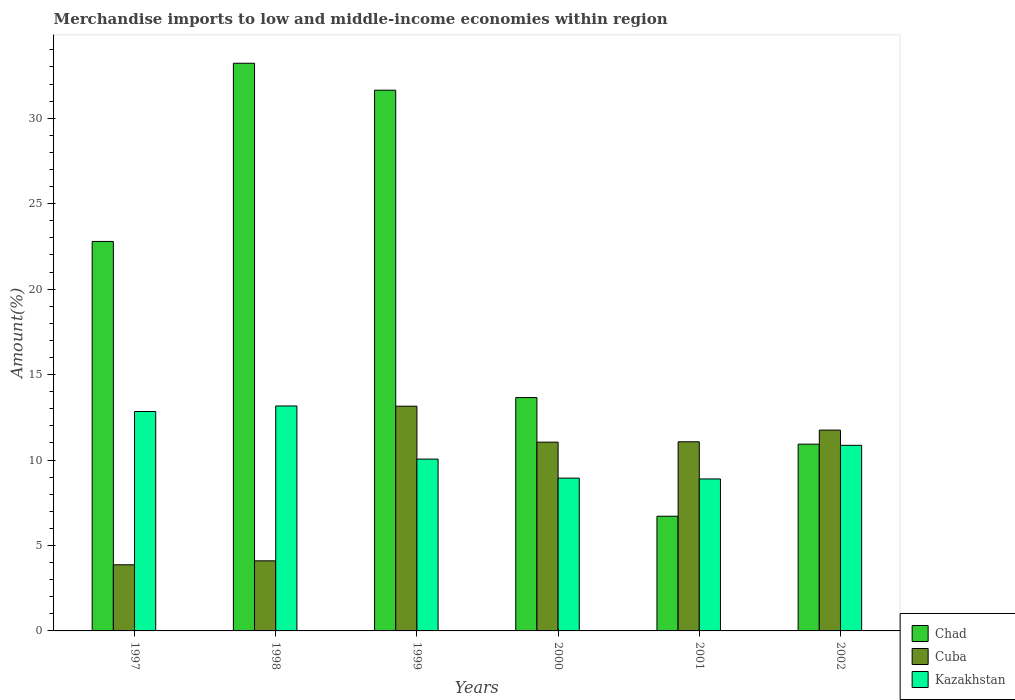How many different coloured bars are there?
Provide a succinct answer. 3. Are the number of bars per tick equal to the number of legend labels?
Provide a short and direct response. Yes. What is the label of the 5th group of bars from the left?
Offer a terse response. 2001. In how many cases, is the number of bars for a given year not equal to the number of legend labels?
Ensure brevity in your answer.  0. What is the percentage of amount earned from merchandise imports in Kazakhstan in 1998?
Provide a short and direct response. 13.16. Across all years, what is the maximum percentage of amount earned from merchandise imports in Cuba?
Offer a very short reply. 13.15. Across all years, what is the minimum percentage of amount earned from merchandise imports in Chad?
Your answer should be very brief. 6.71. In which year was the percentage of amount earned from merchandise imports in Chad minimum?
Make the answer very short. 2001. What is the total percentage of amount earned from merchandise imports in Kazakhstan in the graph?
Offer a very short reply. 64.75. What is the difference between the percentage of amount earned from merchandise imports in Cuba in 1997 and that in 1999?
Give a very brief answer. -9.28. What is the difference between the percentage of amount earned from merchandise imports in Kazakhstan in 1998 and the percentage of amount earned from merchandise imports in Chad in 2002?
Offer a very short reply. 2.24. What is the average percentage of amount earned from merchandise imports in Chad per year?
Your answer should be very brief. 19.82. In the year 1997, what is the difference between the percentage of amount earned from merchandise imports in Chad and percentage of amount earned from merchandise imports in Cuba?
Keep it short and to the point. 18.92. What is the ratio of the percentage of amount earned from merchandise imports in Kazakhstan in 1998 to that in 2001?
Offer a very short reply. 1.48. What is the difference between the highest and the second highest percentage of amount earned from merchandise imports in Kazakhstan?
Your answer should be compact. 0.32. What is the difference between the highest and the lowest percentage of amount earned from merchandise imports in Kazakhstan?
Make the answer very short. 4.27. What does the 3rd bar from the left in 2002 represents?
Ensure brevity in your answer.  Kazakhstan. What does the 2nd bar from the right in 2000 represents?
Make the answer very short. Cuba. Is it the case that in every year, the sum of the percentage of amount earned from merchandise imports in Kazakhstan and percentage of amount earned from merchandise imports in Chad is greater than the percentage of amount earned from merchandise imports in Cuba?
Your response must be concise. Yes. How many bars are there?
Offer a terse response. 18. Are all the bars in the graph horizontal?
Give a very brief answer. No. How many years are there in the graph?
Your answer should be compact. 6. Are the values on the major ticks of Y-axis written in scientific E-notation?
Your answer should be compact. No. Does the graph contain grids?
Offer a very short reply. No. How are the legend labels stacked?
Offer a terse response. Vertical. What is the title of the graph?
Offer a terse response. Merchandise imports to low and middle-income economies within region. Does "Nigeria" appear as one of the legend labels in the graph?
Offer a very short reply. No. What is the label or title of the X-axis?
Your response must be concise. Years. What is the label or title of the Y-axis?
Provide a succinct answer. Amount(%). What is the Amount(%) of Chad in 1997?
Your response must be concise. 22.79. What is the Amount(%) in Cuba in 1997?
Your answer should be compact. 3.87. What is the Amount(%) in Kazakhstan in 1997?
Your answer should be compact. 12.84. What is the Amount(%) of Chad in 1998?
Provide a short and direct response. 33.21. What is the Amount(%) in Cuba in 1998?
Your answer should be very brief. 4.1. What is the Amount(%) in Kazakhstan in 1998?
Offer a very short reply. 13.16. What is the Amount(%) in Chad in 1999?
Your answer should be compact. 31.64. What is the Amount(%) of Cuba in 1999?
Give a very brief answer. 13.15. What is the Amount(%) in Kazakhstan in 1999?
Your response must be concise. 10.05. What is the Amount(%) of Chad in 2000?
Make the answer very short. 13.65. What is the Amount(%) of Cuba in 2000?
Provide a succinct answer. 11.05. What is the Amount(%) in Kazakhstan in 2000?
Your response must be concise. 8.94. What is the Amount(%) of Chad in 2001?
Make the answer very short. 6.71. What is the Amount(%) in Cuba in 2001?
Make the answer very short. 11.07. What is the Amount(%) in Kazakhstan in 2001?
Ensure brevity in your answer.  8.89. What is the Amount(%) of Chad in 2002?
Make the answer very short. 10.93. What is the Amount(%) in Cuba in 2002?
Give a very brief answer. 11.75. What is the Amount(%) of Kazakhstan in 2002?
Provide a short and direct response. 10.86. Across all years, what is the maximum Amount(%) in Chad?
Provide a short and direct response. 33.21. Across all years, what is the maximum Amount(%) of Cuba?
Offer a very short reply. 13.15. Across all years, what is the maximum Amount(%) of Kazakhstan?
Provide a succinct answer. 13.16. Across all years, what is the minimum Amount(%) of Chad?
Ensure brevity in your answer.  6.71. Across all years, what is the minimum Amount(%) of Cuba?
Provide a succinct answer. 3.87. Across all years, what is the minimum Amount(%) in Kazakhstan?
Offer a terse response. 8.89. What is the total Amount(%) in Chad in the graph?
Provide a short and direct response. 118.93. What is the total Amount(%) of Cuba in the graph?
Keep it short and to the point. 54.98. What is the total Amount(%) in Kazakhstan in the graph?
Ensure brevity in your answer.  64.75. What is the difference between the Amount(%) in Chad in 1997 and that in 1998?
Your answer should be compact. -10.43. What is the difference between the Amount(%) of Cuba in 1997 and that in 1998?
Ensure brevity in your answer.  -0.23. What is the difference between the Amount(%) in Kazakhstan in 1997 and that in 1998?
Keep it short and to the point. -0.32. What is the difference between the Amount(%) in Chad in 1997 and that in 1999?
Provide a short and direct response. -8.85. What is the difference between the Amount(%) in Cuba in 1997 and that in 1999?
Ensure brevity in your answer.  -9.28. What is the difference between the Amount(%) of Kazakhstan in 1997 and that in 1999?
Keep it short and to the point. 2.79. What is the difference between the Amount(%) of Chad in 1997 and that in 2000?
Give a very brief answer. 9.13. What is the difference between the Amount(%) in Cuba in 1997 and that in 2000?
Your response must be concise. -7.18. What is the difference between the Amount(%) of Kazakhstan in 1997 and that in 2000?
Give a very brief answer. 3.9. What is the difference between the Amount(%) in Chad in 1997 and that in 2001?
Give a very brief answer. 16.08. What is the difference between the Amount(%) in Cuba in 1997 and that in 2001?
Offer a very short reply. -7.2. What is the difference between the Amount(%) of Kazakhstan in 1997 and that in 2001?
Your response must be concise. 3.95. What is the difference between the Amount(%) of Chad in 1997 and that in 2002?
Provide a short and direct response. 11.86. What is the difference between the Amount(%) in Cuba in 1997 and that in 2002?
Offer a terse response. -7.88. What is the difference between the Amount(%) of Kazakhstan in 1997 and that in 2002?
Give a very brief answer. 1.98. What is the difference between the Amount(%) in Chad in 1998 and that in 1999?
Give a very brief answer. 1.58. What is the difference between the Amount(%) in Cuba in 1998 and that in 1999?
Provide a short and direct response. -9.05. What is the difference between the Amount(%) of Kazakhstan in 1998 and that in 1999?
Ensure brevity in your answer.  3.11. What is the difference between the Amount(%) of Chad in 1998 and that in 2000?
Give a very brief answer. 19.56. What is the difference between the Amount(%) in Cuba in 1998 and that in 2000?
Give a very brief answer. -6.94. What is the difference between the Amount(%) of Kazakhstan in 1998 and that in 2000?
Provide a succinct answer. 4.22. What is the difference between the Amount(%) of Chad in 1998 and that in 2001?
Ensure brevity in your answer.  26.5. What is the difference between the Amount(%) in Cuba in 1998 and that in 2001?
Give a very brief answer. -6.97. What is the difference between the Amount(%) in Kazakhstan in 1998 and that in 2001?
Provide a succinct answer. 4.27. What is the difference between the Amount(%) in Chad in 1998 and that in 2002?
Your answer should be compact. 22.29. What is the difference between the Amount(%) in Cuba in 1998 and that in 2002?
Make the answer very short. -7.65. What is the difference between the Amount(%) in Kazakhstan in 1998 and that in 2002?
Make the answer very short. 2.3. What is the difference between the Amount(%) in Chad in 1999 and that in 2000?
Keep it short and to the point. 17.98. What is the difference between the Amount(%) of Cuba in 1999 and that in 2000?
Your answer should be very brief. 2.1. What is the difference between the Amount(%) of Kazakhstan in 1999 and that in 2000?
Your answer should be compact. 1.11. What is the difference between the Amount(%) of Chad in 1999 and that in 2001?
Make the answer very short. 24.93. What is the difference between the Amount(%) in Cuba in 1999 and that in 2001?
Provide a short and direct response. 2.08. What is the difference between the Amount(%) in Kazakhstan in 1999 and that in 2001?
Provide a succinct answer. 1.16. What is the difference between the Amount(%) in Chad in 1999 and that in 2002?
Your answer should be very brief. 20.71. What is the difference between the Amount(%) of Cuba in 1999 and that in 2002?
Provide a short and direct response. 1.4. What is the difference between the Amount(%) of Kazakhstan in 1999 and that in 2002?
Provide a short and direct response. -0.81. What is the difference between the Amount(%) in Chad in 2000 and that in 2001?
Give a very brief answer. 6.94. What is the difference between the Amount(%) of Cuba in 2000 and that in 2001?
Keep it short and to the point. -0.02. What is the difference between the Amount(%) of Kazakhstan in 2000 and that in 2001?
Your answer should be very brief. 0.05. What is the difference between the Amount(%) in Chad in 2000 and that in 2002?
Give a very brief answer. 2.73. What is the difference between the Amount(%) in Cuba in 2000 and that in 2002?
Ensure brevity in your answer.  -0.71. What is the difference between the Amount(%) of Kazakhstan in 2000 and that in 2002?
Your answer should be compact. -1.92. What is the difference between the Amount(%) in Chad in 2001 and that in 2002?
Offer a terse response. -4.22. What is the difference between the Amount(%) of Cuba in 2001 and that in 2002?
Give a very brief answer. -0.68. What is the difference between the Amount(%) of Kazakhstan in 2001 and that in 2002?
Give a very brief answer. -1.97. What is the difference between the Amount(%) in Chad in 1997 and the Amount(%) in Cuba in 1998?
Your answer should be very brief. 18.69. What is the difference between the Amount(%) of Chad in 1997 and the Amount(%) of Kazakhstan in 1998?
Your response must be concise. 9.63. What is the difference between the Amount(%) of Cuba in 1997 and the Amount(%) of Kazakhstan in 1998?
Offer a terse response. -9.29. What is the difference between the Amount(%) of Chad in 1997 and the Amount(%) of Cuba in 1999?
Your response must be concise. 9.64. What is the difference between the Amount(%) of Chad in 1997 and the Amount(%) of Kazakhstan in 1999?
Your answer should be compact. 12.74. What is the difference between the Amount(%) of Cuba in 1997 and the Amount(%) of Kazakhstan in 1999?
Provide a short and direct response. -6.18. What is the difference between the Amount(%) in Chad in 1997 and the Amount(%) in Cuba in 2000?
Provide a short and direct response. 11.74. What is the difference between the Amount(%) of Chad in 1997 and the Amount(%) of Kazakhstan in 2000?
Offer a terse response. 13.85. What is the difference between the Amount(%) in Cuba in 1997 and the Amount(%) in Kazakhstan in 2000?
Ensure brevity in your answer.  -5.07. What is the difference between the Amount(%) of Chad in 1997 and the Amount(%) of Cuba in 2001?
Provide a succinct answer. 11.72. What is the difference between the Amount(%) of Chad in 1997 and the Amount(%) of Kazakhstan in 2001?
Keep it short and to the point. 13.9. What is the difference between the Amount(%) of Cuba in 1997 and the Amount(%) of Kazakhstan in 2001?
Provide a succinct answer. -5.02. What is the difference between the Amount(%) in Chad in 1997 and the Amount(%) in Cuba in 2002?
Ensure brevity in your answer.  11.04. What is the difference between the Amount(%) of Chad in 1997 and the Amount(%) of Kazakhstan in 2002?
Offer a terse response. 11.93. What is the difference between the Amount(%) in Cuba in 1997 and the Amount(%) in Kazakhstan in 2002?
Keep it short and to the point. -6.99. What is the difference between the Amount(%) in Chad in 1998 and the Amount(%) in Cuba in 1999?
Provide a short and direct response. 20.07. What is the difference between the Amount(%) in Chad in 1998 and the Amount(%) in Kazakhstan in 1999?
Provide a short and direct response. 23.16. What is the difference between the Amount(%) of Cuba in 1998 and the Amount(%) of Kazakhstan in 1999?
Your response must be concise. -5.95. What is the difference between the Amount(%) of Chad in 1998 and the Amount(%) of Cuba in 2000?
Give a very brief answer. 22.17. What is the difference between the Amount(%) in Chad in 1998 and the Amount(%) in Kazakhstan in 2000?
Your answer should be very brief. 24.27. What is the difference between the Amount(%) of Cuba in 1998 and the Amount(%) of Kazakhstan in 2000?
Your response must be concise. -4.84. What is the difference between the Amount(%) of Chad in 1998 and the Amount(%) of Cuba in 2001?
Give a very brief answer. 22.15. What is the difference between the Amount(%) in Chad in 1998 and the Amount(%) in Kazakhstan in 2001?
Offer a very short reply. 24.32. What is the difference between the Amount(%) in Cuba in 1998 and the Amount(%) in Kazakhstan in 2001?
Ensure brevity in your answer.  -4.79. What is the difference between the Amount(%) of Chad in 1998 and the Amount(%) of Cuba in 2002?
Make the answer very short. 21.46. What is the difference between the Amount(%) in Chad in 1998 and the Amount(%) in Kazakhstan in 2002?
Provide a succinct answer. 22.35. What is the difference between the Amount(%) in Cuba in 1998 and the Amount(%) in Kazakhstan in 2002?
Offer a terse response. -6.76. What is the difference between the Amount(%) of Chad in 1999 and the Amount(%) of Cuba in 2000?
Offer a very short reply. 20.59. What is the difference between the Amount(%) in Chad in 1999 and the Amount(%) in Kazakhstan in 2000?
Ensure brevity in your answer.  22.7. What is the difference between the Amount(%) of Cuba in 1999 and the Amount(%) of Kazakhstan in 2000?
Your answer should be very brief. 4.21. What is the difference between the Amount(%) in Chad in 1999 and the Amount(%) in Cuba in 2001?
Give a very brief answer. 20.57. What is the difference between the Amount(%) of Chad in 1999 and the Amount(%) of Kazakhstan in 2001?
Your answer should be compact. 22.75. What is the difference between the Amount(%) of Cuba in 1999 and the Amount(%) of Kazakhstan in 2001?
Provide a succinct answer. 4.26. What is the difference between the Amount(%) in Chad in 1999 and the Amount(%) in Cuba in 2002?
Keep it short and to the point. 19.89. What is the difference between the Amount(%) in Chad in 1999 and the Amount(%) in Kazakhstan in 2002?
Give a very brief answer. 20.78. What is the difference between the Amount(%) of Cuba in 1999 and the Amount(%) of Kazakhstan in 2002?
Offer a terse response. 2.29. What is the difference between the Amount(%) of Chad in 2000 and the Amount(%) of Cuba in 2001?
Your response must be concise. 2.59. What is the difference between the Amount(%) in Chad in 2000 and the Amount(%) in Kazakhstan in 2001?
Offer a very short reply. 4.76. What is the difference between the Amount(%) of Cuba in 2000 and the Amount(%) of Kazakhstan in 2001?
Provide a short and direct response. 2.15. What is the difference between the Amount(%) of Chad in 2000 and the Amount(%) of Cuba in 2002?
Your answer should be very brief. 1.9. What is the difference between the Amount(%) in Chad in 2000 and the Amount(%) in Kazakhstan in 2002?
Provide a short and direct response. 2.79. What is the difference between the Amount(%) of Cuba in 2000 and the Amount(%) of Kazakhstan in 2002?
Keep it short and to the point. 0.18. What is the difference between the Amount(%) of Chad in 2001 and the Amount(%) of Cuba in 2002?
Your answer should be very brief. -5.04. What is the difference between the Amount(%) in Chad in 2001 and the Amount(%) in Kazakhstan in 2002?
Make the answer very short. -4.15. What is the difference between the Amount(%) of Cuba in 2001 and the Amount(%) of Kazakhstan in 2002?
Your answer should be very brief. 0.21. What is the average Amount(%) in Chad per year?
Offer a very short reply. 19.82. What is the average Amount(%) in Cuba per year?
Provide a succinct answer. 9.16. What is the average Amount(%) in Kazakhstan per year?
Your answer should be very brief. 10.79. In the year 1997, what is the difference between the Amount(%) of Chad and Amount(%) of Cuba?
Give a very brief answer. 18.92. In the year 1997, what is the difference between the Amount(%) in Chad and Amount(%) in Kazakhstan?
Provide a short and direct response. 9.95. In the year 1997, what is the difference between the Amount(%) in Cuba and Amount(%) in Kazakhstan?
Provide a succinct answer. -8.97. In the year 1998, what is the difference between the Amount(%) in Chad and Amount(%) in Cuba?
Offer a terse response. 29.11. In the year 1998, what is the difference between the Amount(%) of Chad and Amount(%) of Kazakhstan?
Provide a short and direct response. 20.05. In the year 1998, what is the difference between the Amount(%) in Cuba and Amount(%) in Kazakhstan?
Keep it short and to the point. -9.06. In the year 1999, what is the difference between the Amount(%) of Chad and Amount(%) of Cuba?
Offer a very short reply. 18.49. In the year 1999, what is the difference between the Amount(%) of Chad and Amount(%) of Kazakhstan?
Offer a terse response. 21.59. In the year 1999, what is the difference between the Amount(%) in Cuba and Amount(%) in Kazakhstan?
Your answer should be compact. 3.1. In the year 2000, what is the difference between the Amount(%) in Chad and Amount(%) in Cuba?
Provide a short and direct response. 2.61. In the year 2000, what is the difference between the Amount(%) of Chad and Amount(%) of Kazakhstan?
Your answer should be compact. 4.71. In the year 2000, what is the difference between the Amount(%) of Cuba and Amount(%) of Kazakhstan?
Provide a short and direct response. 2.11. In the year 2001, what is the difference between the Amount(%) of Chad and Amount(%) of Cuba?
Provide a succinct answer. -4.36. In the year 2001, what is the difference between the Amount(%) in Chad and Amount(%) in Kazakhstan?
Keep it short and to the point. -2.18. In the year 2001, what is the difference between the Amount(%) in Cuba and Amount(%) in Kazakhstan?
Your answer should be compact. 2.17. In the year 2002, what is the difference between the Amount(%) of Chad and Amount(%) of Cuba?
Keep it short and to the point. -0.82. In the year 2002, what is the difference between the Amount(%) of Chad and Amount(%) of Kazakhstan?
Your response must be concise. 0.07. In the year 2002, what is the difference between the Amount(%) of Cuba and Amount(%) of Kazakhstan?
Offer a terse response. 0.89. What is the ratio of the Amount(%) in Chad in 1997 to that in 1998?
Your response must be concise. 0.69. What is the ratio of the Amount(%) of Cuba in 1997 to that in 1998?
Provide a short and direct response. 0.94. What is the ratio of the Amount(%) of Kazakhstan in 1997 to that in 1998?
Offer a terse response. 0.98. What is the ratio of the Amount(%) of Chad in 1997 to that in 1999?
Ensure brevity in your answer.  0.72. What is the ratio of the Amount(%) of Cuba in 1997 to that in 1999?
Keep it short and to the point. 0.29. What is the ratio of the Amount(%) of Kazakhstan in 1997 to that in 1999?
Ensure brevity in your answer.  1.28. What is the ratio of the Amount(%) of Chad in 1997 to that in 2000?
Ensure brevity in your answer.  1.67. What is the ratio of the Amount(%) of Cuba in 1997 to that in 2000?
Make the answer very short. 0.35. What is the ratio of the Amount(%) of Kazakhstan in 1997 to that in 2000?
Provide a short and direct response. 1.44. What is the ratio of the Amount(%) in Chad in 1997 to that in 2001?
Ensure brevity in your answer.  3.4. What is the ratio of the Amount(%) in Cuba in 1997 to that in 2001?
Provide a short and direct response. 0.35. What is the ratio of the Amount(%) in Kazakhstan in 1997 to that in 2001?
Your answer should be compact. 1.44. What is the ratio of the Amount(%) in Chad in 1997 to that in 2002?
Offer a terse response. 2.09. What is the ratio of the Amount(%) in Cuba in 1997 to that in 2002?
Make the answer very short. 0.33. What is the ratio of the Amount(%) in Kazakhstan in 1997 to that in 2002?
Offer a very short reply. 1.18. What is the ratio of the Amount(%) in Chad in 1998 to that in 1999?
Your response must be concise. 1.05. What is the ratio of the Amount(%) in Cuba in 1998 to that in 1999?
Your response must be concise. 0.31. What is the ratio of the Amount(%) in Kazakhstan in 1998 to that in 1999?
Give a very brief answer. 1.31. What is the ratio of the Amount(%) of Chad in 1998 to that in 2000?
Provide a succinct answer. 2.43. What is the ratio of the Amount(%) of Cuba in 1998 to that in 2000?
Give a very brief answer. 0.37. What is the ratio of the Amount(%) of Kazakhstan in 1998 to that in 2000?
Make the answer very short. 1.47. What is the ratio of the Amount(%) of Chad in 1998 to that in 2001?
Your response must be concise. 4.95. What is the ratio of the Amount(%) of Cuba in 1998 to that in 2001?
Ensure brevity in your answer.  0.37. What is the ratio of the Amount(%) in Kazakhstan in 1998 to that in 2001?
Keep it short and to the point. 1.48. What is the ratio of the Amount(%) in Chad in 1998 to that in 2002?
Keep it short and to the point. 3.04. What is the ratio of the Amount(%) of Cuba in 1998 to that in 2002?
Make the answer very short. 0.35. What is the ratio of the Amount(%) in Kazakhstan in 1998 to that in 2002?
Provide a succinct answer. 1.21. What is the ratio of the Amount(%) of Chad in 1999 to that in 2000?
Offer a very short reply. 2.32. What is the ratio of the Amount(%) in Cuba in 1999 to that in 2000?
Ensure brevity in your answer.  1.19. What is the ratio of the Amount(%) in Kazakhstan in 1999 to that in 2000?
Your answer should be compact. 1.12. What is the ratio of the Amount(%) of Chad in 1999 to that in 2001?
Ensure brevity in your answer.  4.71. What is the ratio of the Amount(%) of Cuba in 1999 to that in 2001?
Ensure brevity in your answer.  1.19. What is the ratio of the Amount(%) in Kazakhstan in 1999 to that in 2001?
Your answer should be very brief. 1.13. What is the ratio of the Amount(%) of Chad in 1999 to that in 2002?
Provide a succinct answer. 2.9. What is the ratio of the Amount(%) of Cuba in 1999 to that in 2002?
Your answer should be compact. 1.12. What is the ratio of the Amount(%) in Kazakhstan in 1999 to that in 2002?
Your answer should be very brief. 0.93. What is the ratio of the Amount(%) of Chad in 2000 to that in 2001?
Provide a succinct answer. 2.03. What is the ratio of the Amount(%) of Cuba in 2000 to that in 2001?
Your answer should be very brief. 1. What is the ratio of the Amount(%) in Kazakhstan in 2000 to that in 2001?
Ensure brevity in your answer.  1.01. What is the ratio of the Amount(%) of Chad in 2000 to that in 2002?
Ensure brevity in your answer.  1.25. What is the ratio of the Amount(%) of Kazakhstan in 2000 to that in 2002?
Offer a very short reply. 0.82. What is the ratio of the Amount(%) in Chad in 2001 to that in 2002?
Provide a succinct answer. 0.61. What is the ratio of the Amount(%) of Cuba in 2001 to that in 2002?
Offer a terse response. 0.94. What is the ratio of the Amount(%) in Kazakhstan in 2001 to that in 2002?
Ensure brevity in your answer.  0.82. What is the difference between the highest and the second highest Amount(%) of Chad?
Provide a succinct answer. 1.58. What is the difference between the highest and the second highest Amount(%) in Cuba?
Make the answer very short. 1.4. What is the difference between the highest and the second highest Amount(%) in Kazakhstan?
Give a very brief answer. 0.32. What is the difference between the highest and the lowest Amount(%) in Chad?
Your answer should be very brief. 26.5. What is the difference between the highest and the lowest Amount(%) in Cuba?
Your answer should be very brief. 9.28. What is the difference between the highest and the lowest Amount(%) in Kazakhstan?
Your response must be concise. 4.27. 